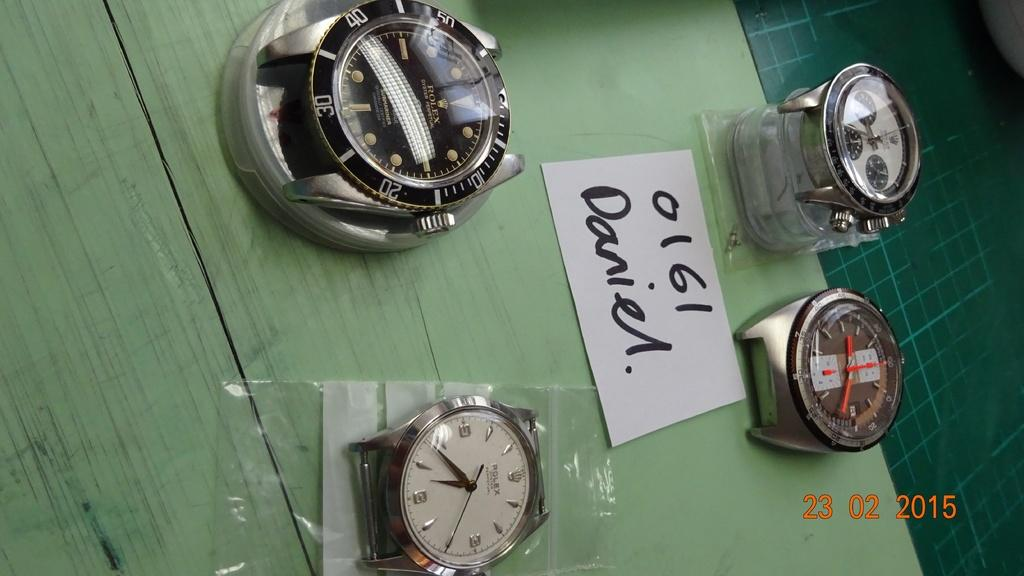<image>
Provide a brief description of the given image. a message on paper with watches that says daniel 